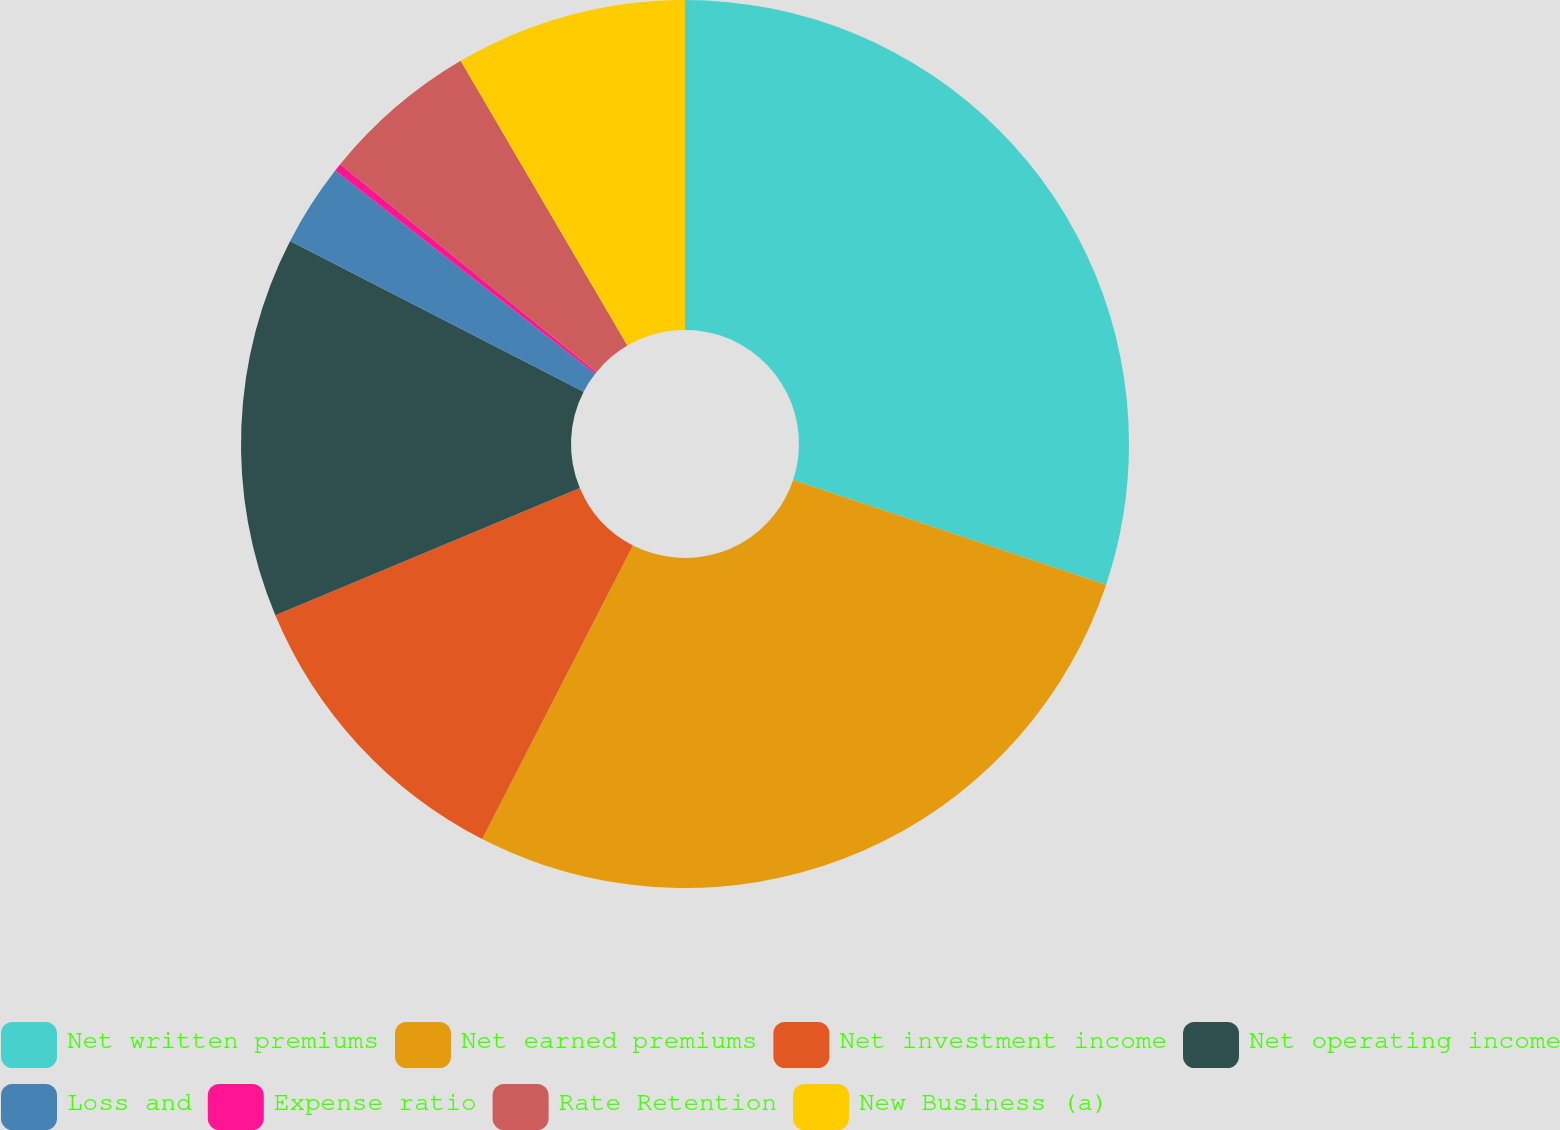Convert chart. <chart><loc_0><loc_0><loc_500><loc_500><pie_chart><fcel>Net written premiums<fcel>Net earned premiums<fcel>Net investment income<fcel>Net operating income<fcel>Loss and<fcel>Expense ratio<fcel>Rate Retention<fcel>New Business (a)<nl><fcel>30.13%<fcel>27.42%<fcel>11.15%<fcel>13.86%<fcel>3.0%<fcel>0.29%<fcel>5.72%<fcel>8.43%<nl></chart> 